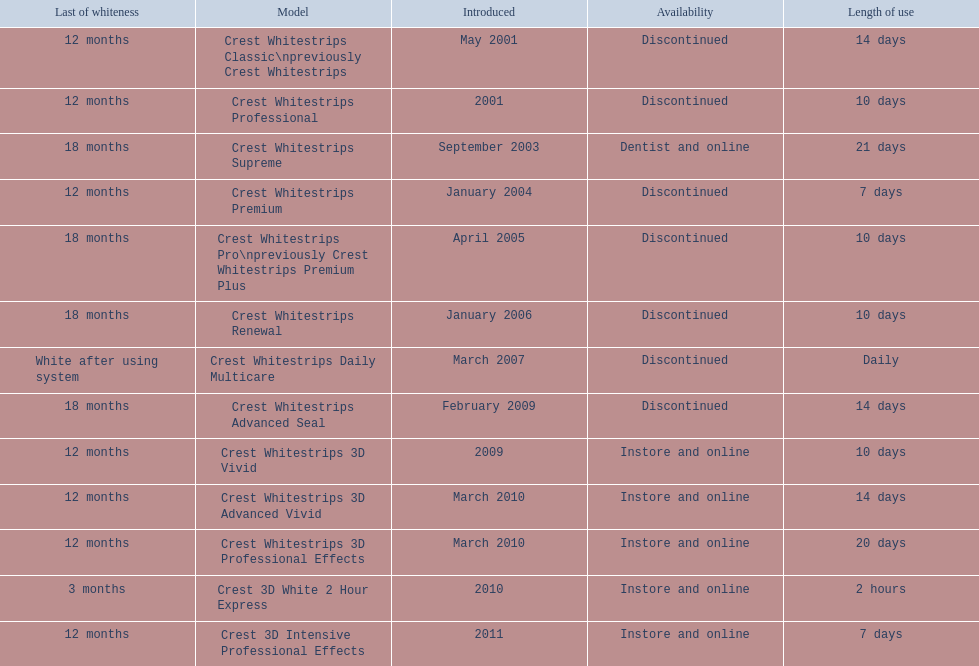When was crest whitestrips 3d advanced vivid introduced? March 2010. Write the full table. {'header': ['Last of whiteness', 'Model', 'Introduced', 'Availability', 'Length of use'], 'rows': [['12 months', 'Crest Whitestrips Classic\\npreviously Crest Whitestrips', 'May 2001', 'Discontinued', '14 days'], ['12 months', 'Crest Whitestrips Professional', '2001', 'Discontinued', '10 days'], ['18 months', 'Crest Whitestrips Supreme', 'September 2003', 'Dentist and online', '21 days'], ['12 months', 'Crest Whitestrips Premium', 'January 2004', 'Discontinued', '7 days'], ['18 months', 'Crest Whitestrips Pro\\npreviously Crest Whitestrips Premium Plus', 'April 2005', 'Discontinued', '10 days'], ['18 months', 'Crest Whitestrips Renewal', 'January 2006', 'Discontinued', '10 days'], ['White after using system', 'Crest Whitestrips Daily Multicare', 'March 2007', 'Discontinued', 'Daily'], ['18 months', 'Crest Whitestrips Advanced Seal', 'February 2009', 'Discontinued', '14 days'], ['12 months', 'Crest Whitestrips 3D Vivid', '2009', 'Instore and online', '10 days'], ['12 months', 'Crest Whitestrips 3D Advanced Vivid', 'March 2010', 'Instore and online', '14 days'], ['12 months', 'Crest Whitestrips 3D Professional Effects', 'March 2010', 'Instore and online', '20 days'], ['3 months', 'Crest 3D White 2 Hour Express', '2010', 'Instore and online', '2 hours'], ['12 months', 'Crest 3D Intensive Professional Effects', '2011', 'Instore and online', '7 days']]} What other product was introduced in march 2010? Crest Whitestrips 3D Professional Effects. 